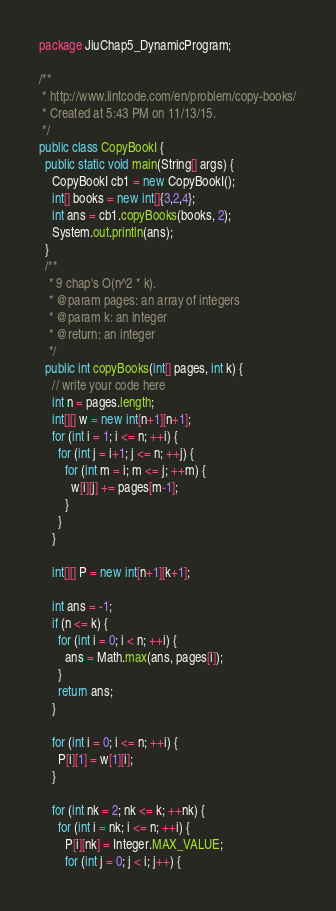Convert code to text. <code><loc_0><loc_0><loc_500><loc_500><_Java_>package JiuChap5_DynamicProgram;

/**
 * http://www.lintcode.com/en/problem/copy-books/
 * Created at 5:43 PM on 11/13/15.
 */
public class CopyBookI {
  public static void main(String[] args) {
    CopyBookI cb1 = new CopyBookI();
    int[] books = new int[]{3,2,4};
    int ans = cb1.copyBooks(books, 2);
    System.out.println(ans);
  }
  /**
   * 9 chap's O(n^2 * k).
   * @param pages: an array of integers
   * @param k: an integer
   * @return: an integer
   */
  public int copyBooks(int[] pages, int k) {
    // write your code here
    int n = pages.length;
    int[][] w = new int[n+1][n+1];
    for (int i = 1; i <= n; ++i) {
      for (int j = i+1; j <= n; ++j) {
        for (int m = i; m <= j; ++m) {
          w[i][j] += pages[m-1];
        }
      }
    }

    int[][] P = new int[n+1][k+1];

    int ans = -1;
    if (n <= k) {
      for (int i = 0; i < n; ++i) {
        ans = Math.max(ans, pages[i]);
      }
      return ans;
    }

    for (int i = 0; i <= n; ++i) {
      P[i][1] = w[1][i];
    }

    for (int nk = 2; nk <= k; ++nk) {
      for (int i = nk; i <= n; ++i) {
        P[i][nk] = Integer.MAX_VALUE;
        for (int j = 0; j < i; j++) {</code> 